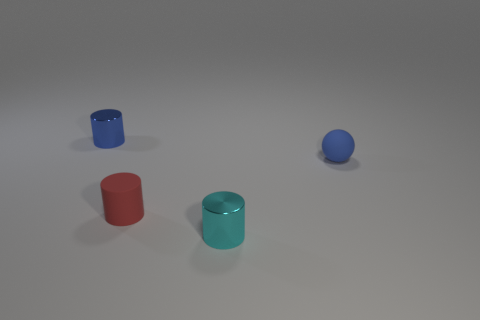Add 4 blue objects. How many objects exist? 8 Subtract all cylinders. How many objects are left? 1 Add 2 tiny cyan cylinders. How many tiny cyan cylinders are left? 3 Add 3 purple matte cylinders. How many purple matte cylinders exist? 3 Subtract 0 yellow spheres. How many objects are left? 4 Subtract all large rubber cylinders. Subtract all cyan objects. How many objects are left? 3 